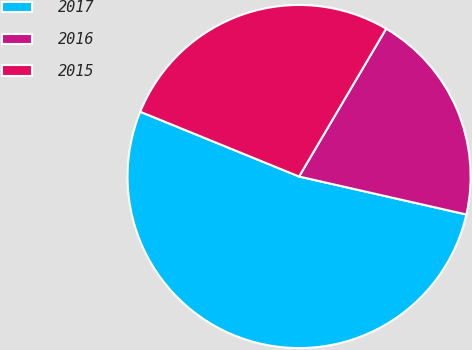Convert chart. <chart><loc_0><loc_0><loc_500><loc_500><pie_chart><fcel>2017<fcel>2016<fcel>2015<nl><fcel>52.61%<fcel>20.08%<fcel>27.31%<nl></chart> 